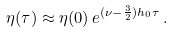Convert formula to latex. <formula><loc_0><loc_0><loc_500><loc_500>\eta ( \tau ) \approx \eta ( 0 ) \, e ^ { ( \nu - \frac { 3 } { 2 } ) h _ { 0 } \tau } \, .</formula> 